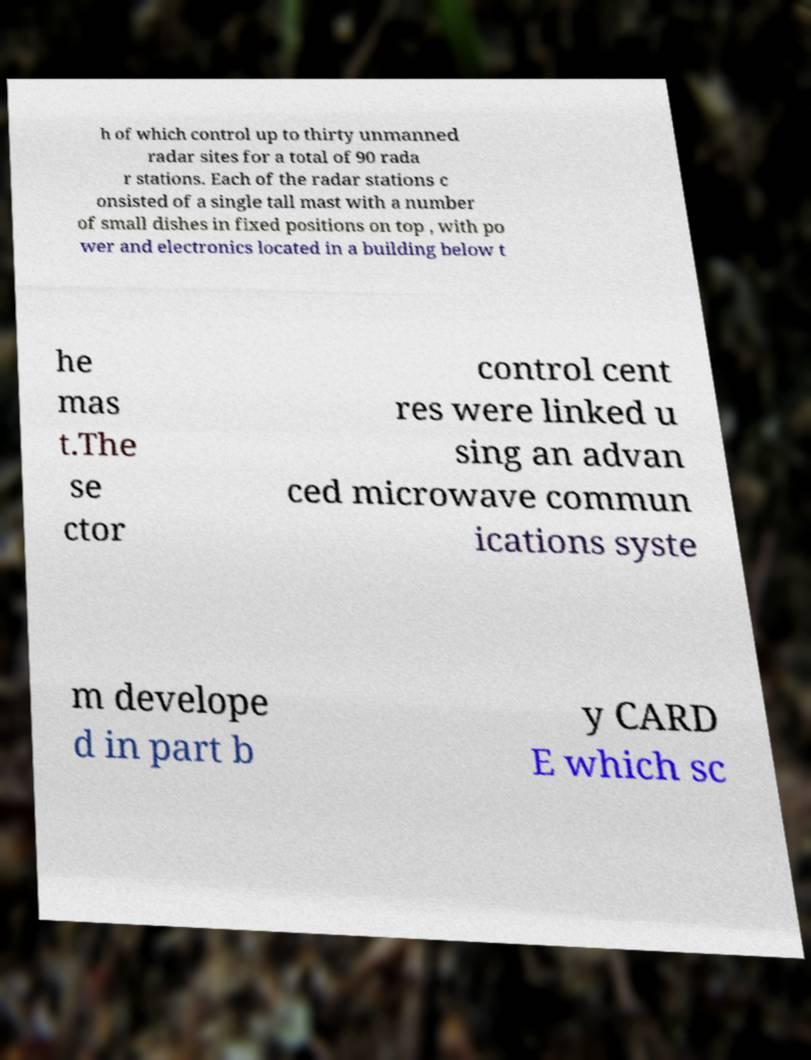Can you accurately transcribe the text from the provided image for me? h of which control up to thirty unmanned radar sites for a total of 90 rada r stations. Each of the radar stations c onsisted of a single tall mast with a number of small dishes in fixed positions on top , with po wer and electronics located in a building below t he mas t.The se ctor control cent res were linked u sing an advan ced microwave commun ications syste m develope d in part b y CARD E which sc 